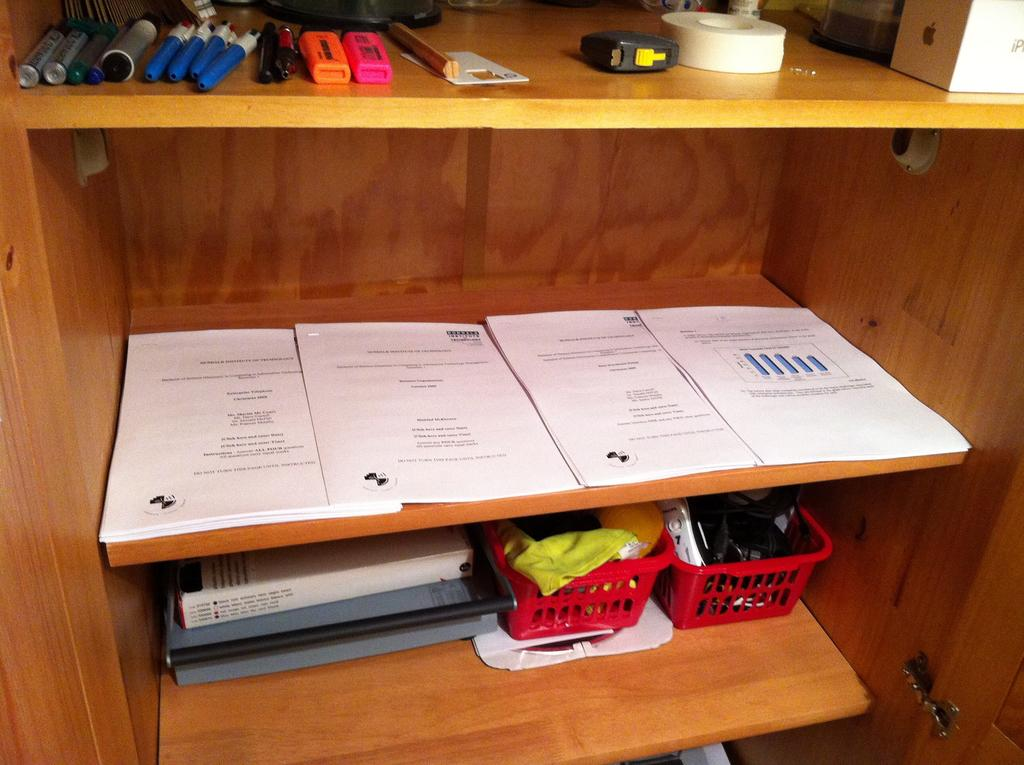What type of furniture is visible in the image? There is a shelf in the image. What items can be seen on the shelf? Papers, files, baskets, markers, pens, and tape are present on the shelf. Are there any other objects on the shelf besides the ones mentioned? Yes, there are other objects placed on the shelf. What advice does the brother give about organizing the shelf in the image? There is no brother present in the image, nor is there any advice given about organizing the shelf. 